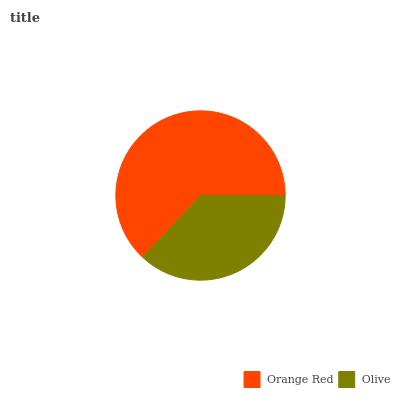Is Olive the minimum?
Answer yes or no. Yes. Is Orange Red the maximum?
Answer yes or no. Yes. Is Olive the maximum?
Answer yes or no. No. Is Orange Red greater than Olive?
Answer yes or no. Yes. Is Olive less than Orange Red?
Answer yes or no. Yes. Is Olive greater than Orange Red?
Answer yes or no. No. Is Orange Red less than Olive?
Answer yes or no. No. Is Orange Red the high median?
Answer yes or no. Yes. Is Olive the low median?
Answer yes or no. Yes. Is Olive the high median?
Answer yes or no. No. Is Orange Red the low median?
Answer yes or no. No. 